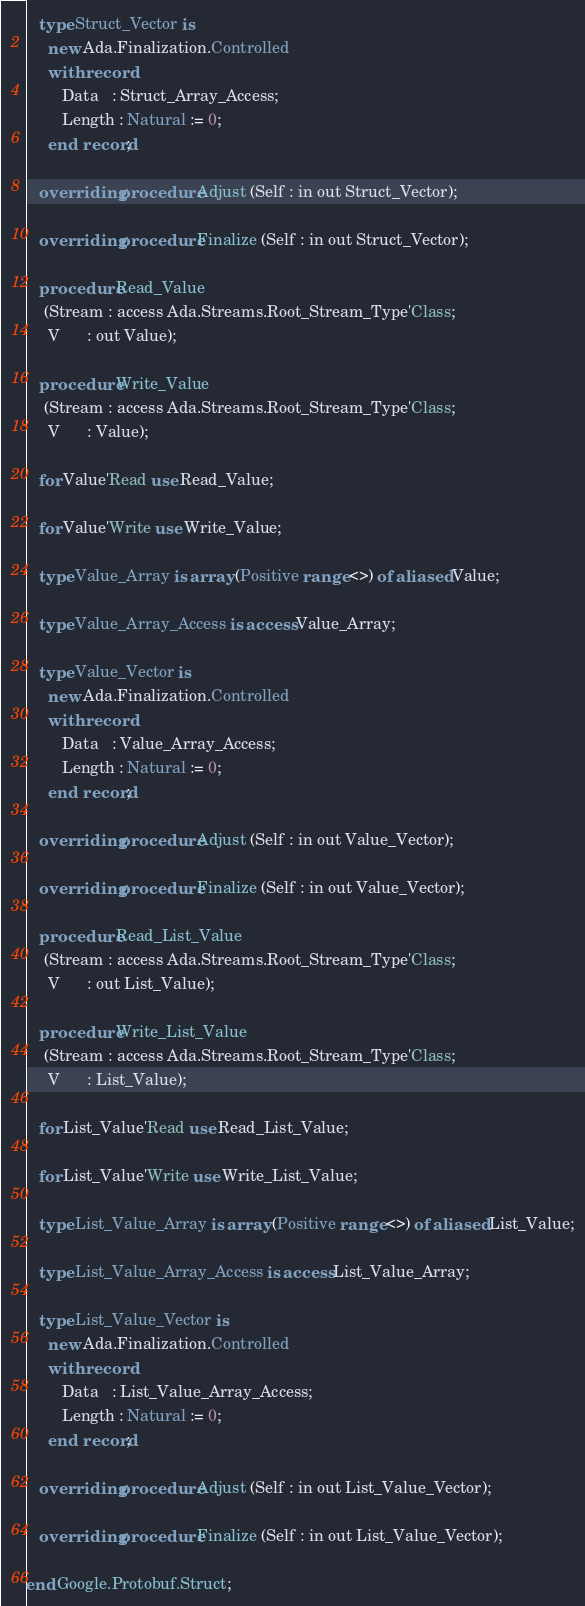<code> <loc_0><loc_0><loc_500><loc_500><_Ada_>
   type Struct_Vector is
     new Ada.Finalization.Controlled
     with record
        Data   : Struct_Array_Access;
        Length : Natural := 0;
     end record;

   overriding procedure Adjust (Self : in out Struct_Vector);

   overriding procedure Finalize (Self : in out Struct_Vector);

   procedure Read_Value
    (Stream : access Ada.Streams.Root_Stream_Type'Class;
     V      : out Value);

   procedure Write_Value
    (Stream : access Ada.Streams.Root_Stream_Type'Class;
     V      : Value);

   for Value'Read use Read_Value;

   for Value'Write use Write_Value;

   type Value_Array is array (Positive range <>) of aliased Value;

   type Value_Array_Access is access Value_Array;

   type Value_Vector is
     new Ada.Finalization.Controlled
     with record
        Data   : Value_Array_Access;
        Length : Natural := 0;
     end record;

   overriding procedure Adjust (Self : in out Value_Vector);

   overriding procedure Finalize (Self : in out Value_Vector);

   procedure Read_List_Value
    (Stream : access Ada.Streams.Root_Stream_Type'Class;
     V      : out List_Value);

   procedure Write_List_Value
    (Stream : access Ada.Streams.Root_Stream_Type'Class;
     V      : List_Value);

   for List_Value'Read use Read_List_Value;

   for List_Value'Write use Write_List_Value;

   type List_Value_Array is array (Positive range <>) of aliased List_Value;

   type List_Value_Array_Access is access List_Value_Array;

   type List_Value_Vector is
     new Ada.Finalization.Controlled
     with record
        Data   : List_Value_Array_Access;
        Length : Natural := 0;
     end record;

   overriding procedure Adjust (Self : in out List_Value_Vector);

   overriding procedure Finalize (Self : in out List_Value_Vector);

end Google.Protobuf.Struct;</code> 